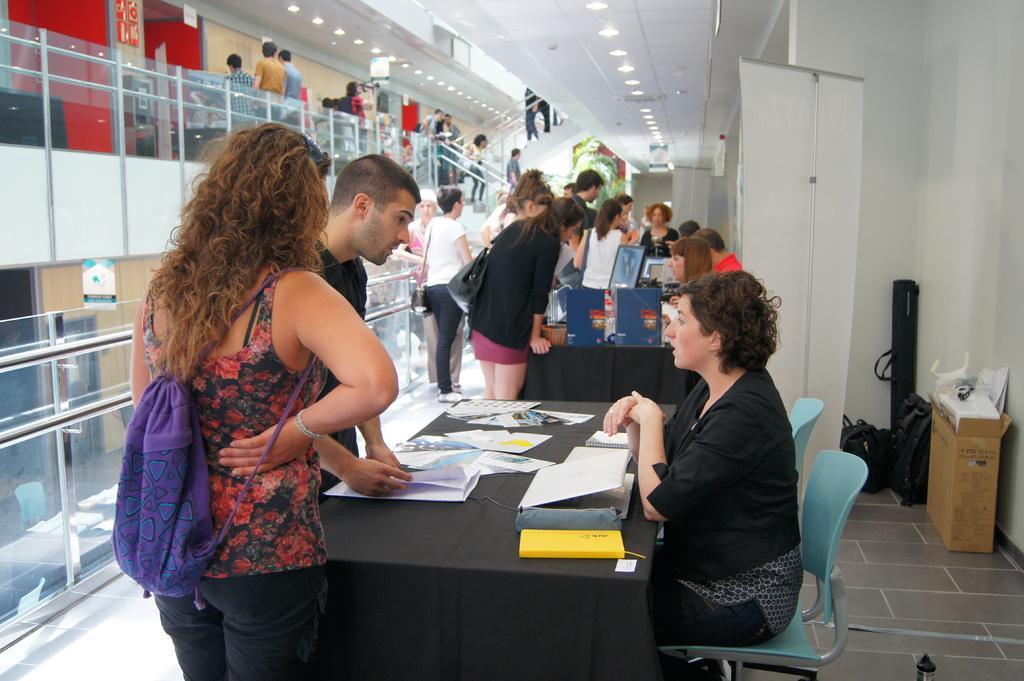How would you summarize this image in a sentence or two? In this image there are group of people standing near the table and in table there are papers, box , there is a woman sitting in chair , and in back ground there are group of persons standing, lights , speaker , cardboard box. 